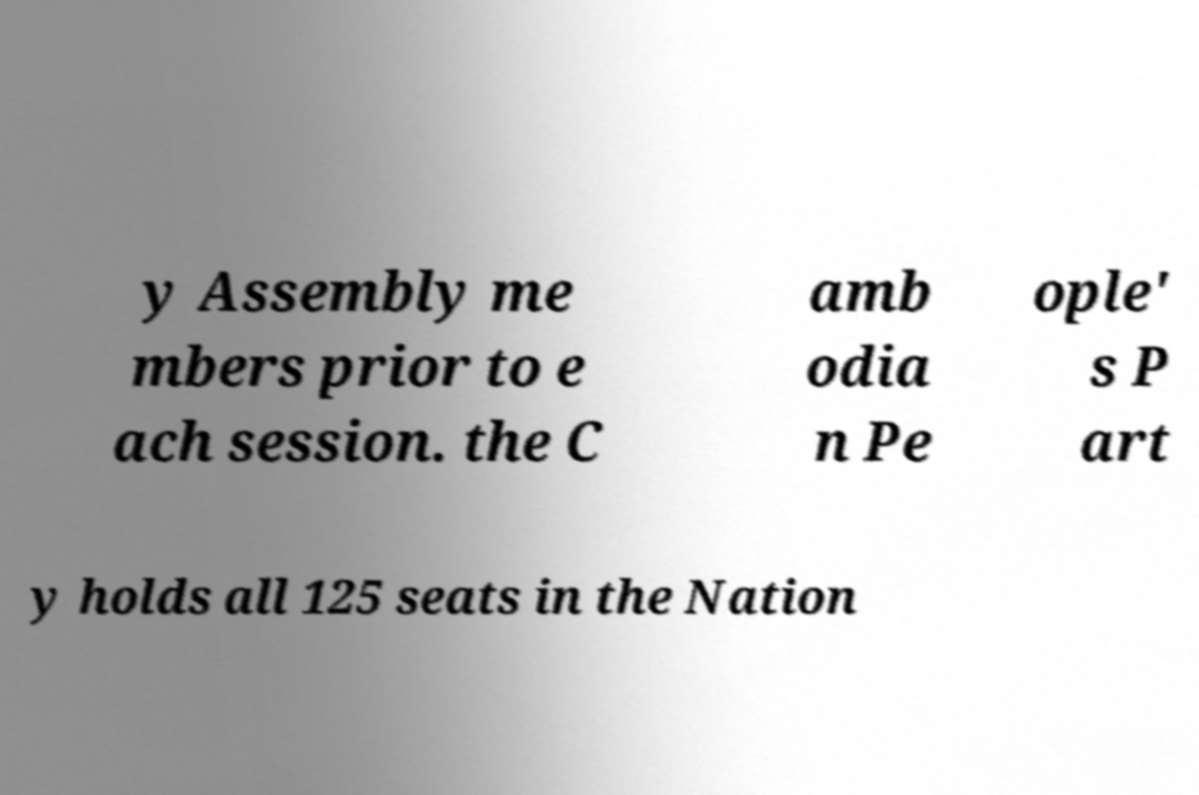There's text embedded in this image that I need extracted. Can you transcribe it verbatim? y Assembly me mbers prior to e ach session. the C amb odia n Pe ople' s P art y holds all 125 seats in the Nation 